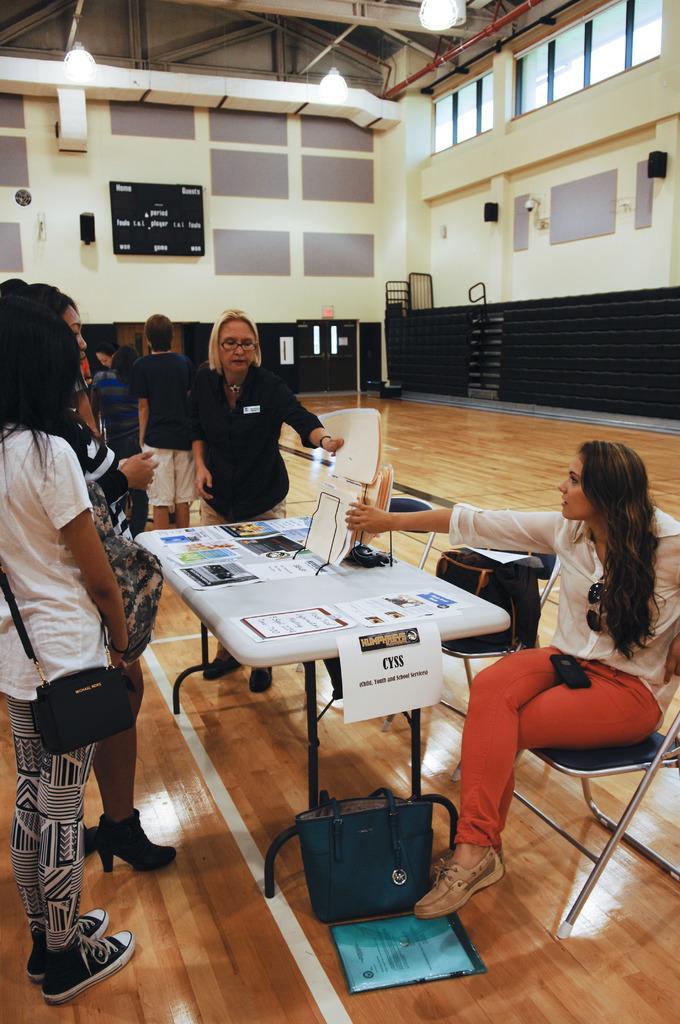In one or two sentences, can you explain what this image depicts? here in this process we can see a stadium,here we can also see a chair ,woman is sitting,on the table we can see some of the woman standing near the table. 